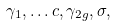Convert formula to latex. <formula><loc_0><loc_0><loc_500><loc_500>\gamma _ { 1 } , \dots c , \gamma _ { 2 g } , \sigma ,</formula> 